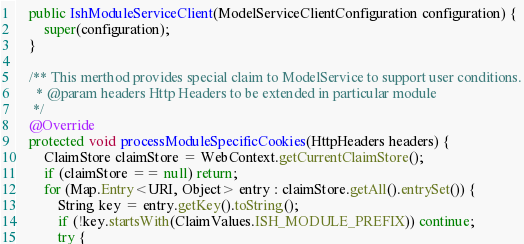Convert code to text. <code><loc_0><loc_0><loc_500><loc_500><_Java_>    public IshModuleServiceClient(ModelServiceClientConfiguration configuration) {
        super(configuration);
    }

    /** This merthod provides special claim to ModelService to support user conditions.
      * @param headers Http Headers to be extended in particular module
     */
    @Override
    protected void processModuleSpecificCookies(HttpHeaders headers) {
        ClaimStore claimStore = WebContext.getCurrentClaimStore();
        if (claimStore == null) return;
        for (Map.Entry<URI, Object> entry : claimStore.getAll().entrySet()) {
            String key = entry.getKey().toString();
            if (!key.startsWith(ClaimValues.ISH_MODULE_PREFIX)) continue;
            try {</code> 